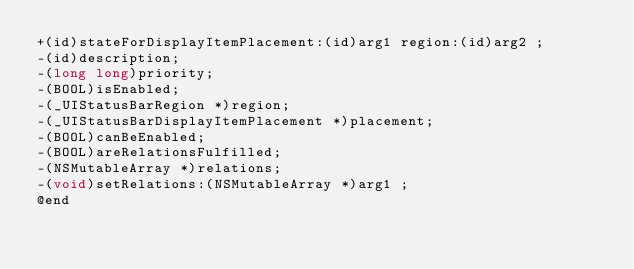<code> <loc_0><loc_0><loc_500><loc_500><_C_>+(id)stateForDisplayItemPlacement:(id)arg1 region:(id)arg2 ;
-(id)description;
-(long long)priority;
-(BOOL)isEnabled;
-(_UIStatusBarRegion *)region;
-(_UIStatusBarDisplayItemPlacement *)placement;
-(BOOL)canBeEnabled;
-(BOOL)areRelationsFulfilled;
-(NSMutableArray *)relations;
-(void)setRelations:(NSMutableArray *)arg1 ;
@end

</code> 